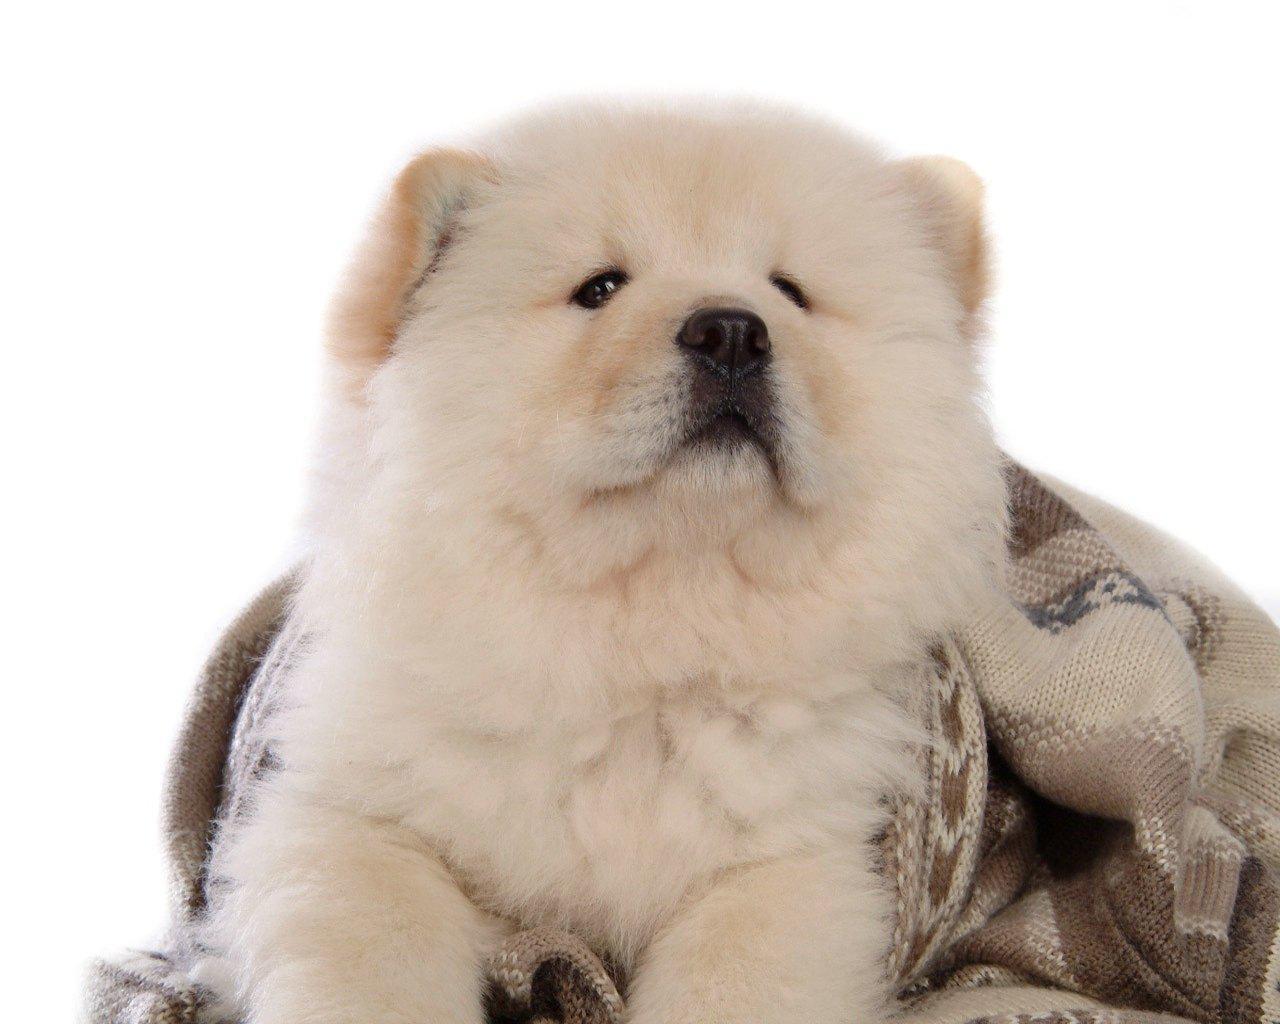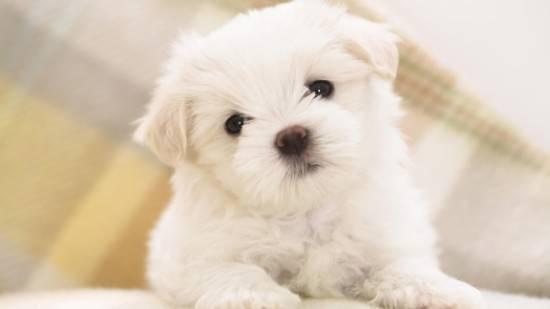The first image is the image on the left, the second image is the image on the right. Analyze the images presented: Is the assertion "The dogs in the two images look virtually identical." valid? Answer yes or no. No. 